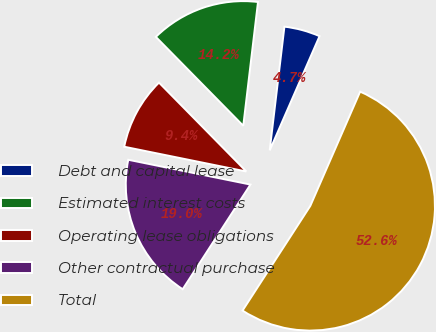Convert chart. <chart><loc_0><loc_0><loc_500><loc_500><pie_chart><fcel>Debt and capital lease<fcel>Estimated interest costs<fcel>Operating lease obligations<fcel>Other contractual purchase<fcel>Total<nl><fcel>4.66%<fcel>14.25%<fcel>9.45%<fcel>19.04%<fcel>52.6%<nl></chart> 